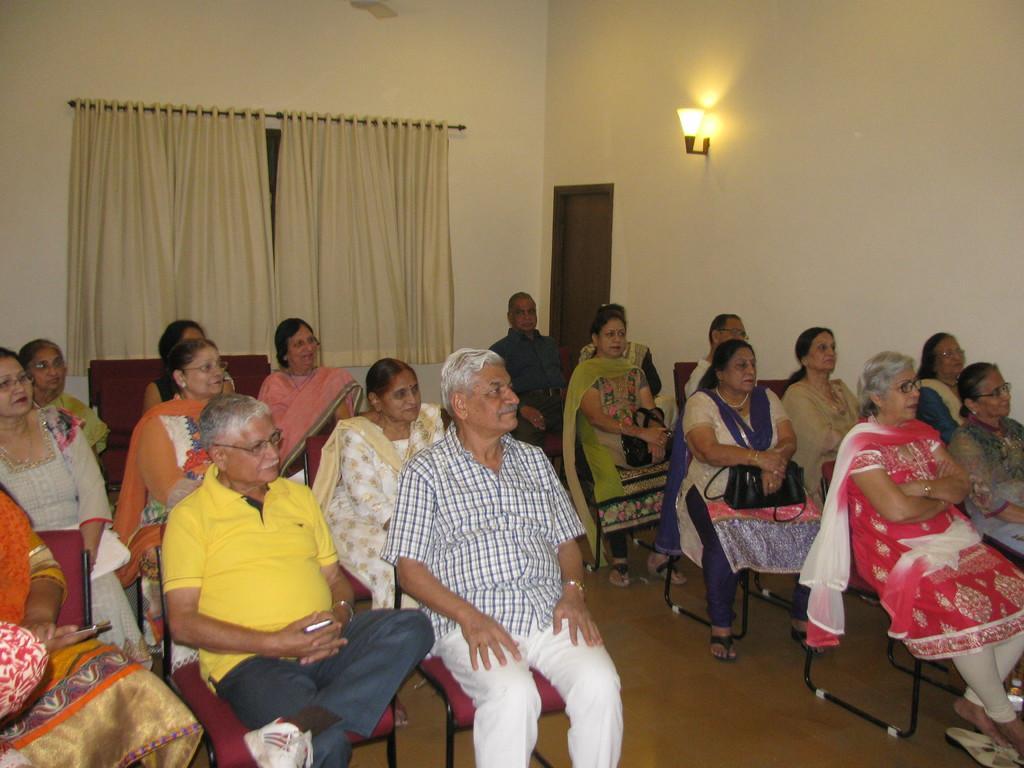Can you describe this image briefly? In this picture I can observe some people sitting in the chairs. There are men and women in this picture. On the right side I can observe a lamp fixed to the wall and a door. In the background there are curtains and a wall. 